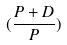Convert formula to latex. <formula><loc_0><loc_0><loc_500><loc_500>( \frac { P + D } { P } )</formula> 